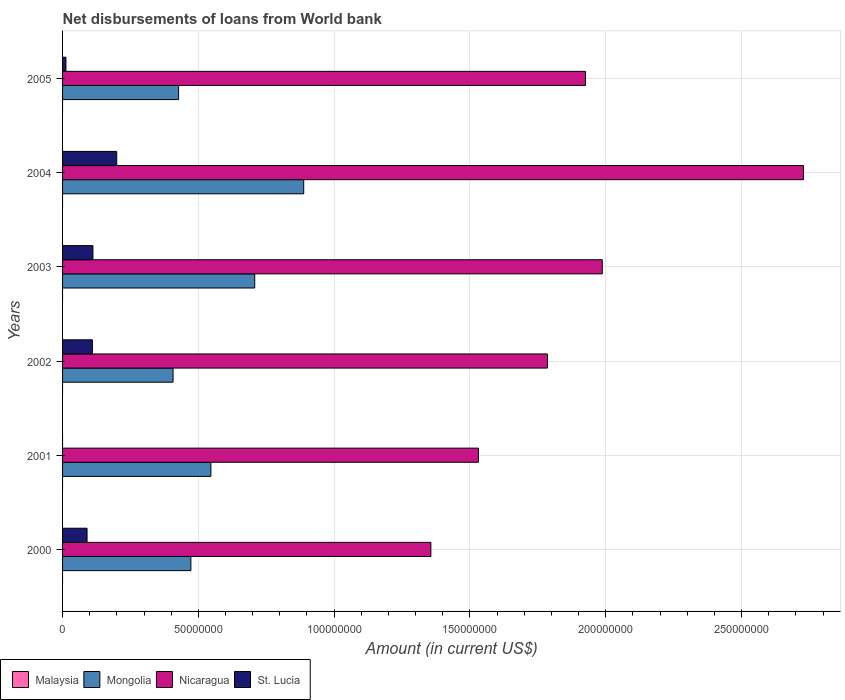How many groups of bars are there?
Offer a very short reply. 6. Are the number of bars per tick equal to the number of legend labels?
Give a very brief answer. No. How many bars are there on the 2nd tick from the top?
Your response must be concise. 3. What is the amount of loan disbursed from World Bank in Mongolia in 2003?
Ensure brevity in your answer.  7.08e+07. Across all years, what is the maximum amount of loan disbursed from World Bank in St. Lucia?
Offer a very short reply. 1.99e+07. Across all years, what is the minimum amount of loan disbursed from World Bank in St. Lucia?
Offer a very short reply. 0. In which year was the amount of loan disbursed from World Bank in Nicaragua maximum?
Offer a terse response. 2004. What is the total amount of loan disbursed from World Bank in St. Lucia in the graph?
Ensure brevity in your answer.  5.24e+07. What is the difference between the amount of loan disbursed from World Bank in St. Lucia in 2000 and that in 2005?
Keep it short and to the point. 7.78e+06. What is the difference between the amount of loan disbursed from World Bank in St. Lucia in 2003 and the amount of loan disbursed from World Bank in Mongolia in 2002?
Keep it short and to the point. -2.95e+07. What is the average amount of loan disbursed from World Bank in St. Lucia per year?
Offer a very short reply. 8.73e+06. In the year 2003, what is the difference between the amount of loan disbursed from World Bank in St. Lucia and amount of loan disbursed from World Bank in Mongolia?
Make the answer very short. -5.96e+07. In how many years, is the amount of loan disbursed from World Bank in Mongolia greater than 200000000 US$?
Your answer should be very brief. 0. What is the ratio of the amount of loan disbursed from World Bank in Nicaragua in 2003 to that in 2005?
Keep it short and to the point. 1.03. Is the amount of loan disbursed from World Bank in St. Lucia in 2003 less than that in 2004?
Provide a short and direct response. Yes. Is the difference between the amount of loan disbursed from World Bank in St. Lucia in 2002 and 2003 greater than the difference between the amount of loan disbursed from World Bank in Mongolia in 2002 and 2003?
Ensure brevity in your answer.  Yes. What is the difference between the highest and the second highest amount of loan disbursed from World Bank in Mongolia?
Ensure brevity in your answer.  1.80e+07. What is the difference between the highest and the lowest amount of loan disbursed from World Bank in Nicaragua?
Offer a terse response. 1.37e+08. In how many years, is the amount of loan disbursed from World Bank in Malaysia greater than the average amount of loan disbursed from World Bank in Malaysia taken over all years?
Provide a short and direct response. 0. Is the sum of the amount of loan disbursed from World Bank in Mongolia in 2001 and 2002 greater than the maximum amount of loan disbursed from World Bank in Malaysia across all years?
Provide a short and direct response. Yes. Is it the case that in every year, the sum of the amount of loan disbursed from World Bank in Mongolia and amount of loan disbursed from World Bank in Malaysia is greater than the sum of amount of loan disbursed from World Bank in St. Lucia and amount of loan disbursed from World Bank in Nicaragua?
Your response must be concise. No. How many bars are there?
Your response must be concise. 17. Are all the bars in the graph horizontal?
Provide a short and direct response. Yes. How many years are there in the graph?
Offer a very short reply. 6. What is the difference between two consecutive major ticks on the X-axis?
Keep it short and to the point. 5.00e+07. Are the values on the major ticks of X-axis written in scientific E-notation?
Give a very brief answer. No. Does the graph contain any zero values?
Provide a succinct answer. Yes. Does the graph contain grids?
Your answer should be very brief. Yes. How many legend labels are there?
Provide a succinct answer. 4. What is the title of the graph?
Offer a terse response. Net disbursements of loans from World bank. Does "Palau" appear as one of the legend labels in the graph?
Offer a very short reply. No. What is the Amount (in current US$) in Malaysia in 2000?
Offer a very short reply. 0. What is the Amount (in current US$) of Mongolia in 2000?
Provide a short and direct response. 4.72e+07. What is the Amount (in current US$) of Nicaragua in 2000?
Offer a very short reply. 1.36e+08. What is the Amount (in current US$) of St. Lucia in 2000?
Offer a very short reply. 9.02e+06. What is the Amount (in current US$) in Mongolia in 2001?
Give a very brief answer. 5.46e+07. What is the Amount (in current US$) in Nicaragua in 2001?
Provide a short and direct response. 1.53e+08. What is the Amount (in current US$) in Mongolia in 2002?
Your answer should be compact. 4.07e+07. What is the Amount (in current US$) of Nicaragua in 2002?
Provide a short and direct response. 1.79e+08. What is the Amount (in current US$) of St. Lucia in 2002?
Ensure brevity in your answer.  1.10e+07. What is the Amount (in current US$) of Mongolia in 2003?
Provide a short and direct response. 7.08e+07. What is the Amount (in current US$) of Nicaragua in 2003?
Offer a very short reply. 1.99e+08. What is the Amount (in current US$) in St. Lucia in 2003?
Provide a short and direct response. 1.12e+07. What is the Amount (in current US$) of Mongolia in 2004?
Offer a very short reply. 8.88e+07. What is the Amount (in current US$) in Nicaragua in 2004?
Keep it short and to the point. 2.73e+08. What is the Amount (in current US$) of St. Lucia in 2004?
Make the answer very short. 1.99e+07. What is the Amount (in current US$) in Mongolia in 2005?
Offer a terse response. 4.27e+07. What is the Amount (in current US$) in Nicaragua in 2005?
Keep it short and to the point. 1.93e+08. What is the Amount (in current US$) of St. Lucia in 2005?
Make the answer very short. 1.24e+06. Across all years, what is the maximum Amount (in current US$) in Mongolia?
Make the answer very short. 8.88e+07. Across all years, what is the maximum Amount (in current US$) of Nicaragua?
Your answer should be compact. 2.73e+08. Across all years, what is the maximum Amount (in current US$) of St. Lucia?
Your answer should be very brief. 1.99e+07. Across all years, what is the minimum Amount (in current US$) of Mongolia?
Provide a short and direct response. 4.07e+07. Across all years, what is the minimum Amount (in current US$) of Nicaragua?
Provide a succinct answer. 1.36e+08. What is the total Amount (in current US$) of Mongolia in the graph?
Ensure brevity in your answer.  3.45e+08. What is the total Amount (in current US$) of Nicaragua in the graph?
Keep it short and to the point. 1.13e+09. What is the total Amount (in current US$) of St. Lucia in the graph?
Your answer should be compact. 5.24e+07. What is the difference between the Amount (in current US$) of Mongolia in 2000 and that in 2001?
Your answer should be very brief. -7.37e+06. What is the difference between the Amount (in current US$) in Nicaragua in 2000 and that in 2001?
Keep it short and to the point. -1.75e+07. What is the difference between the Amount (in current US$) of Mongolia in 2000 and that in 2002?
Make the answer very short. 6.56e+06. What is the difference between the Amount (in current US$) in Nicaragua in 2000 and that in 2002?
Offer a very short reply. -4.29e+07. What is the difference between the Amount (in current US$) in St. Lucia in 2000 and that in 2002?
Provide a short and direct response. -1.96e+06. What is the difference between the Amount (in current US$) of Mongolia in 2000 and that in 2003?
Keep it short and to the point. -2.35e+07. What is the difference between the Amount (in current US$) of Nicaragua in 2000 and that in 2003?
Provide a succinct answer. -6.31e+07. What is the difference between the Amount (in current US$) of St. Lucia in 2000 and that in 2003?
Provide a succinct answer. -2.16e+06. What is the difference between the Amount (in current US$) of Mongolia in 2000 and that in 2004?
Offer a very short reply. -4.15e+07. What is the difference between the Amount (in current US$) of Nicaragua in 2000 and that in 2004?
Offer a terse response. -1.37e+08. What is the difference between the Amount (in current US$) in St. Lucia in 2000 and that in 2004?
Ensure brevity in your answer.  -1.09e+07. What is the difference between the Amount (in current US$) in Mongolia in 2000 and that in 2005?
Offer a terse response. 4.53e+06. What is the difference between the Amount (in current US$) of Nicaragua in 2000 and that in 2005?
Ensure brevity in your answer.  -5.69e+07. What is the difference between the Amount (in current US$) in St. Lucia in 2000 and that in 2005?
Make the answer very short. 7.78e+06. What is the difference between the Amount (in current US$) in Mongolia in 2001 and that in 2002?
Your answer should be very brief. 1.39e+07. What is the difference between the Amount (in current US$) of Nicaragua in 2001 and that in 2002?
Your answer should be compact. -2.54e+07. What is the difference between the Amount (in current US$) of Mongolia in 2001 and that in 2003?
Provide a short and direct response. -1.61e+07. What is the difference between the Amount (in current US$) of Nicaragua in 2001 and that in 2003?
Give a very brief answer. -4.56e+07. What is the difference between the Amount (in current US$) in Mongolia in 2001 and that in 2004?
Offer a very short reply. -3.42e+07. What is the difference between the Amount (in current US$) in Nicaragua in 2001 and that in 2004?
Ensure brevity in your answer.  -1.20e+08. What is the difference between the Amount (in current US$) in Mongolia in 2001 and that in 2005?
Keep it short and to the point. 1.19e+07. What is the difference between the Amount (in current US$) in Nicaragua in 2001 and that in 2005?
Offer a terse response. -3.94e+07. What is the difference between the Amount (in current US$) in Mongolia in 2002 and that in 2003?
Your response must be concise. -3.01e+07. What is the difference between the Amount (in current US$) in Nicaragua in 2002 and that in 2003?
Make the answer very short. -2.02e+07. What is the difference between the Amount (in current US$) of St. Lucia in 2002 and that in 2003?
Offer a terse response. -2.05e+05. What is the difference between the Amount (in current US$) in Mongolia in 2002 and that in 2004?
Your answer should be compact. -4.81e+07. What is the difference between the Amount (in current US$) in Nicaragua in 2002 and that in 2004?
Offer a very short reply. -9.43e+07. What is the difference between the Amount (in current US$) in St. Lucia in 2002 and that in 2004?
Your response must be concise. -8.97e+06. What is the difference between the Amount (in current US$) of Mongolia in 2002 and that in 2005?
Offer a terse response. -2.03e+06. What is the difference between the Amount (in current US$) in Nicaragua in 2002 and that in 2005?
Make the answer very short. -1.40e+07. What is the difference between the Amount (in current US$) in St. Lucia in 2002 and that in 2005?
Offer a terse response. 9.73e+06. What is the difference between the Amount (in current US$) in Mongolia in 2003 and that in 2004?
Ensure brevity in your answer.  -1.80e+07. What is the difference between the Amount (in current US$) of Nicaragua in 2003 and that in 2004?
Offer a terse response. -7.41e+07. What is the difference between the Amount (in current US$) in St. Lucia in 2003 and that in 2004?
Your answer should be compact. -8.76e+06. What is the difference between the Amount (in current US$) in Mongolia in 2003 and that in 2005?
Ensure brevity in your answer.  2.80e+07. What is the difference between the Amount (in current US$) in Nicaragua in 2003 and that in 2005?
Your answer should be compact. 6.20e+06. What is the difference between the Amount (in current US$) of St. Lucia in 2003 and that in 2005?
Ensure brevity in your answer.  9.94e+06. What is the difference between the Amount (in current US$) of Mongolia in 2004 and that in 2005?
Make the answer very short. 4.61e+07. What is the difference between the Amount (in current US$) in Nicaragua in 2004 and that in 2005?
Provide a short and direct response. 8.03e+07. What is the difference between the Amount (in current US$) of St. Lucia in 2004 and that in 2005?
Your answer should be compact. 1.87e+07. What is the difference between the Amount (in current US$) of Mongolia in 2000 and the Amount (in current US$) of Nicaragua in 2001?
Provide a short and direct response. -1.06e+08. What is the difference between the Amount (in current US$) of Mongolia in 2000 and the Amount (in current US$) of Nicaragua in 2002?
Your answer should be very brief. -1.31e+08. What is the difference between the Amount (in current US$) in Mongolia in 2000 and the Amount (in current US$) in St. Lucia in 2002?
Your answer should be compact. 3.63e+07. What is the difference between the Amount (in current US$) in Nicaragua in 2000 and the Amount (in current US$) in St. Lucia in 2002?
Your answer should be compact. 1.25e+08. What is the difference between the Amount (in current US$) in Mongolia in 2000 and the Amount (in current US$) in Nicaragua in 2003?
Provide a succinct answer. -1.51e+08. What is the difference between the Amount (in current US$) in Mongolia in 2000 and the Amount (in current US$) in St. Lucia in 2003?
Offer a very short reply. 3.61e+07. What is the difference between the Amount (in current US$) in Nicaragua in 2000 and the Amount (in current US$) in St. Lucia in 2003?
Give a very brief answer. 1.24e+08. What is the difference between the Amount (in current US$) in Mongolia in 2000 and the Amount (in current US$) in Nicaragua in 2004?
Ensure brevity in your answer.  -2.26e+08. What is the difference between the Amount (in current US$) in Mongolia in 2000 and the Amount (in current US$) in St. Lucia in 2004?
Your answer should be compact. 2.73e+07. What is the difference between the Amount (in current US$) in Nicaragua in 2000 and the Amount (in current US$) in St. Lucia in 2004?
Provide a succinct answer. 1.16e+08. What is the difference between the Amount (in current US$) of Mongolia in 2000 and the Amount (in current US$) of Nicaragua in 2005?
Your response must be concise. -1.45e+08. What is the difference between the Amount (in current US$) in Mongolia in 2000 and the Amount (in current US$) in St. Lucia in 2005?
Offer a very short reply. 4.60e+07. What is the difference between the Amount (in current US$) in Nicaragua in 2000 and the Amount (in current US$) in St. Lucia in 2005?
Provide a succinct answer. 1.34e+08. What is the difference between the Amount (in current US$) of Mongolia in 2001 and the Amount (in current US$) of Nicaragua in 2002?
Make the answer very short. -1.24e+08. What is the difference between the Amount (in current US$) of Mongolia in 2001 and the Amount (in current US$) of St. Lucia in 2002?
Your answer should be compact. 4.36e+07. What is the difference between the Amount (in current US$) in Nicaragua in 2001 and the Amount (in current US$) in St. Lucia in 2002?
Offer a terse response. 1.42e+08. What is the difference between the Amount (in current US$) in Mongolia in 2001 and the Amount (in current US$) in Nicaragua in 2003?
Provide a succinct answer. -1.44e+08. What is the difference between the Amount (in current US$) of Mongolia in 2001 and the Amount (in current US$) of St. Lucia in 2003?
Give a very brief answer. 4.34e+07. What is the difference between the Amount (in current US$) of Nicaragua in 2001 and the Amount (in current US$) of St. Lucia in 2003?
Offer a terse response. 1.42e+08. What is the difference between the Amount (in current US$) in Mongolia in 2001 and the Amount (in current US$) in Nicaragua in 2004?
Provide a short and direct response. -2.18e+08. What is the difference between the Amount (in current US$) of Mongolia in 2001 and the Amount (in current US$) of St. Lucia in 2004?
Give a very brief answer. 3.47e+07. What is the difference between the Amount (in current US$) in Nicaragua in 2001 and the Amount (in current US$) in St. Lucia in 2004?
Your response must be concise. 1.33e+08. What is the difference between the Amount (in current US$) in Mongolia in 2001 and the Amount (in current US$) in Nicaragua in 2005?
Offer a terse response. -1.38e+08. What is the difference between the Amount (in current US$) in Mongolia in 2001 and the Amount (in current US$) in St. Lucia in 2005?
Provide a short and direct response. 5.34e+07. What is the difference between the Amount (in current US$) in Nicaragua in 2001 and the Amount (in current US$) in St. Lucia in 2005?
Ensure brevity in your answer.  1.52e+08. What is the difference between the Amount (in current US$) in Mongolia in 2002 and the Amount (in current US$) in Nicaragua in 2003?
Provide a short and direct response. -1.58e+08. What is the difference between the Amount (in current US$) in Mongolia in 2002 and the Amount (in current US$) in St. Lucia in 2003?
Your answer should be compact. 2.95e+07. What is the difference between the Amount (in current US$) of Nicaragua in 2002 and the Amount (in current US$) of St. Lucia in 2003?
Give a very brief answer. 1.67e+08. What is the difference between the Amount (in current US$) of Mongolia in 2002 and the Amount (in current US$) of Nicaragua in 2004?
Make the answer very short. -2.32e+08. What is the difference between the Amount (in current US$) in Mongolia in 2002 and the Amount (in current US$) in St. Lucia in 2004?
Offer a very short reply. 2.07e+07. What is the difference between the Amount (in current US$) in Nicaragua in 2002 and the Amount (in current US$) in St. Lucia in 2004?
Offer a terse response. 1.59e+08. What is the difference between the Amount (in current US$) of Mongolia in 2002 and the Amount (in current US$) of Nicaragua in 2005?
Offer a terse response. -1.52e+08. What is the difference between the Amount (in current US$) of Mongolia in 2002 and the Amount (in current US$) of St. Lucia in 2005?
Give a very brief answer. 3.94e+07. What is the difference between the Amount (in current US$) in Nicaragua in 2002 and the Amount (in current US$) in St. Lucia in 2005?
Provide a short and direct response. 1.77e+08. What is the difference between the Amount (in current US$) of Mongolia in 2003 and the Amount (in current US$) of Nicaragua in 2004?
Provide a succinct answer. -2.02e+08. What is the difference between the Amount (in current US$) of Mongolia in 2003 and the Amount (in current US$) of St. Lucia in 2004?
Your response must be concise. 5.08e+07. What is the difference between the Amount (in current US$) in Nicaragua in 2003 and the Amount (in current US$) in St. Lucia in 2004?
Offer a terse response. 1.79e+08. What is the difference between the Amount (in current US$) of Mongolia in 2003 and the Amount (in current US$) of Nicaragua in 2005?
Your answer should be compact. -1.22e+08. What is the difference between the Amount (in current US$) in Mongolia in 2003 and the Amount (in current US$) in St. Lucia in 2005?
Give a very brief answer. 6.95e+07. What is the difference between the Amount (in current US$) in Nicaragua in 2003 and the Amount (in current US$) in St. Lucia in 2005?
Your answer should be very brief. 1.97e+08. What is the difference between the Amount (in current US$) of Mongolia in 2004 and the Amount (in current US$) of Nicaragua in 2005?
Your answer should be very brief. -1.04e+08. What is the difference between the Amount (in current US$) in Mongolia in 2004 and the Amount (in current US$) in St. Lucia in 2005?
Offer a terse response. 8.76e+07. What is the difference between the Amount (in current US$) in Nicaragua in 2004 and the Amount (in current US$) in St. Lucia in 2005?
Provide a succinct answer. 2.72e+08. What is the average Amount (in current US$) in Mongolia per year?
Your response must be concise. 5.75e+07. What is the average Amount (in current US$) of Nicaragua per year?
Your answer should be compact. 1.89e+08. What is the average Amount (in current US$) in St. Lucia per year?
Provide a short and direct response. 8.73e+06. In the year 2000, what is the difference between the Amount (in current US$) of Mongolia and Amount (in current US$) of Nicaragua?
Your answer should be compact. -8.84e+07. In the year 2000, what is the difference between the Amount (in current US$) of Mongolia and Amount (in current US$) of St. Lucia?
Your response must be concise. 3.82e+07. In the year 2000, what is the difference between the Amount (in current US$) in Nicaragua and Amount (in current US$) in St. Lucia?
Ensure brevity in your answer.  1.27e+08. In the year 2001, what is the difference between the Amount (in current US$) in Mongolia and Amount (in current US$) in Nicaragua?
Give a very brief answer. -9.85e+07. In the year 2002, what is the difference between the Amount (in current US$) in Mongolia and Amount (in current US$) in Nicaragua?
Make the answer very short. -1.38e+08. In the year 2002, what is the difference between the Amount (in current US$) of Mongolia and Amount (in current US$) of St. Lucia?
Offer a terse response. 2.97e+07. In the year 2002, what is the difference between the Amount (in current US$) of Nicaragua and Amount (in current US$) of St. Lucia?
Your answer should be compact. 1.68e+08. In the year 2003, what is the difference between the Amount (in current US$) in Mongolia and Amount (in current US$) in Nicaragua?
Keep it short and to the point. -1.28e+08. In the year 2003, what is the difference between the Amount (in current US$) of Mongolia and Amount (in current US$) of St. Lucia?
Make the answer very short. 5.96e+07. In the year 2003, what is the difference between the Amount (in current US$) in Nicaragua and Amount (in current US$) in St. Lucia?
Give a very brief answer. 1.88e+08. In the year 2004, what is the difference between the Amount (in current US$) in Mongolia and Amount (in current US$) in Nicaragua?
Make the answer very short. -1.84e+08. In the year 2004, what is the difference between the Amount (in current US$) of Mongolia and Amount (in current US$) of St. Lucia?
Make the answer very short. 6.88e+07. In the year 2004, what is the difference between the Amount (in current US$) of Nicaragua and Amount (in current US$) of St. Lucia?
Your answer should be compact. 2.53e+08. In the year 2005, what is the difference between the Amount (in current US$) in Mongolia and Amount (in current US$) in Nicaragua?
Your answer should be very brief. -1.50e+08. In the year 2005, what is the difference between the Amount (in current US$) of Mongolia and Amount (in current US$) of St. Lucia?
Your answer should be very brief. 4.15e+07. In the year 2005, what is the difference between the Amount (in current US$) of Nicaragua and Amount (in current US$) of St. Lucia?
Your answer should be compact. 1.91e+08. What is the ratio of the Amount (in current US$) of Mongolia in 2000 to that in 2001?
Your answer should be very brief. 0.87. What is the ratio of the Amount (in current US$) of Nicaragua in 2000 to that in 2001?
Offer a terse response. 0.89. What is the ratio of the Amount (in current US$) in Mongolia in 2000 to that in 2002?
Offer a very short reply. 1.16. What is the ratio of the Amount (in current US$) in Nicaragua in 2000 to that in 2002?
Ensure brevity in your answer.  0.76. What is the ratio of the Amount (in current US$) of St. Lucia in 2000 to that in 2002?
Your answer should be very brief. 0.82. What is the ratio of the Amount (in current US$) of Mongolia in 2000 to that in 2003?
Provide a short and direct response. 0.67. What is the ratio of the Amount (in current US$) of Nicaragua in 2000 to that in 2003?
Ensure brevity in your answer.  0.68. What is the ratio of the Amount (in current US$) of St. Lucia in 2000 to that in 2003?
Make the answer very short. 0.81. What is the ratio of the Amount (in current US$) of Mongolia in 2000 to that in 2004?
Provide a short and direct response. 0.53. What is the ratio of the Amount (in current US$) in Nicaragua in 2000 to that in 2004?
Your response must be concise. 0.5. What is the ratio of the Amount (in current US$) of St. Lucia in 2000 to that in 2004?
Provide a short and direct response. 0.45. What is the ratio of the Amount (in current US$) of Mongolia in 2000 to that in 2005?
Keep it short and to the point. 1.11. What is the ratio of the Amount (in current US$) of Nicaragua in 2000 to that in 2005?
Ensure brevity in your answer.  0.7. What is the ratio of the Amount (in current US$) of St. Lucia in 2000 to that in 2005?
Provide a succinct answer. 7.26. What is the ratio of the Amount (in current US$) of Mongolia in 2001 to that in 2002?
Give a very brief answer. 1.34. What is the ratio of the Amount (in current US$) in Nicaragua in 2001 to that in 2002?
Your answer should be compact. 0.86. What is the ratio of the Amount (in current US$) of Mongolia in 2001 to that in 2003?
Keep it short and to the point. 0.77. What is the ratio of the Amount (in current US$) of Nicaragua in 2001 to that in 2003?
Your answer should be very brief. 0.77. What is the ratio of the Amount (in current US$) in Mongolia in 2001 to that in 2004?
Your answer should be compact. 0.62. What is the ratio of the Amount (in current US$) of Nicaragua in 2001 to that in 2004?
Make the answer very short. 0.56. What is the ratio of the Amount (in current US$) in Mongolia in 2001 to that in 2005?
Offer a very short reply. 1.28. What is the ratio of the Amount (in current US$) of Nicaragua in 2001 to that in 2005?
Your response must be concise. 0.8. What is the ratio of the Amount (in current US$) in Mongolia in 2002 to that in 2003?
Make the answer very short. 0.58. What is the ratio of the Amount (in current US$) of Nicaragua in 2002 to that in 2003?
Your answer should be very brief. 0.9. What is the ratio of the Amount (in current US$) of St. Lucia in 2002 to that in 2003?
Offer a terse response. 0.98. What is the ratio of the Amount (in current US$) in Mongolia in 2002 to that in 2004?
Keep it short and to the point. 0.46. What is the ratio of the Amount (in current US$) of Nicaragua in 2002 to that in 2004?
Your answer should be very brief. 0.65. What is the ratio of the Amount (in current US$) of St. Lucia in 2002 to that in 2004?
Your answer should be compact. 0.55. What is the ratio of the Amount (in current US$) in Nicaragua in 2002 to that in 2005?
Keep it short and to the point. 0.93. What is the ratio of the Amount (in current US$) in St. Lucia in 2002 to that in 2005?
Your answer should be very brief. 8.83. What is the ratio of the Amount (in current US$) in Mongolia in 2003 to that in 2004?
Provide a succinct answer. 0.8. What is the ratio of the Amount (in current US$) in Nicaragua in 2003 to that in 2004?
Make the answer very short. 0.73. What is the ratio of the Amount (in current US$) of St. Lucia in 2003 to that in 2004?
Make the answer very short. 0.56. What is the ratio of the Amount (in current US$) of Mongolia in 2003 to that in 2005?
Make the answer very short. 1.66. What is the ratio of the Amount (in current US$) of Nicaragua in 2003 to that in 2005?
Offer a terse response. 1.03. What is the ratio of the Amount (in current US$) of St. Lucia in 2003 to that in 2005?
Your response must be concise. 9. What is the ratio of the Amount (in current US$) in Mongolia in 2004 to that in 2005?
Keep it short and to the point. 2.08. What is the ratio of the Amount (in current US$) in Nicaragua in 2004 to that in 2005?
Give a very brief answer. 1.42. What is the ratio of the Amount (in current US$) in St. Lucia in 2004 to that in 2005?
Provide a succinct answer. 16.05. What is the difference between the highest and the second highest Amount (in current US$) in Mongolia?
Keep it short and to the point. 1.80e+07. What is the difference between the highest and the second highest Amount (in current US$) of Nicaragua?
Provide a succinct answer. 7.41e+07. What is the difference between the highest and the second highest Amount (in current US$) in St. Lucia?
Your answer should be very brief. 8.76e+06. What is the difference between the highest and the lowest Amount (in current US$) of Mongolia?
Ensure brevity in your answer.  4.81e+07. What is the difference between the highest and the lowest Amount (in current US$) of Nicaragua?
Offer a very short reply. 1.37e+08. What is the difference between the highest and the lowest Amount (in current US$) of St. Lucia?
Offer a terse response. 1.99e+07. 